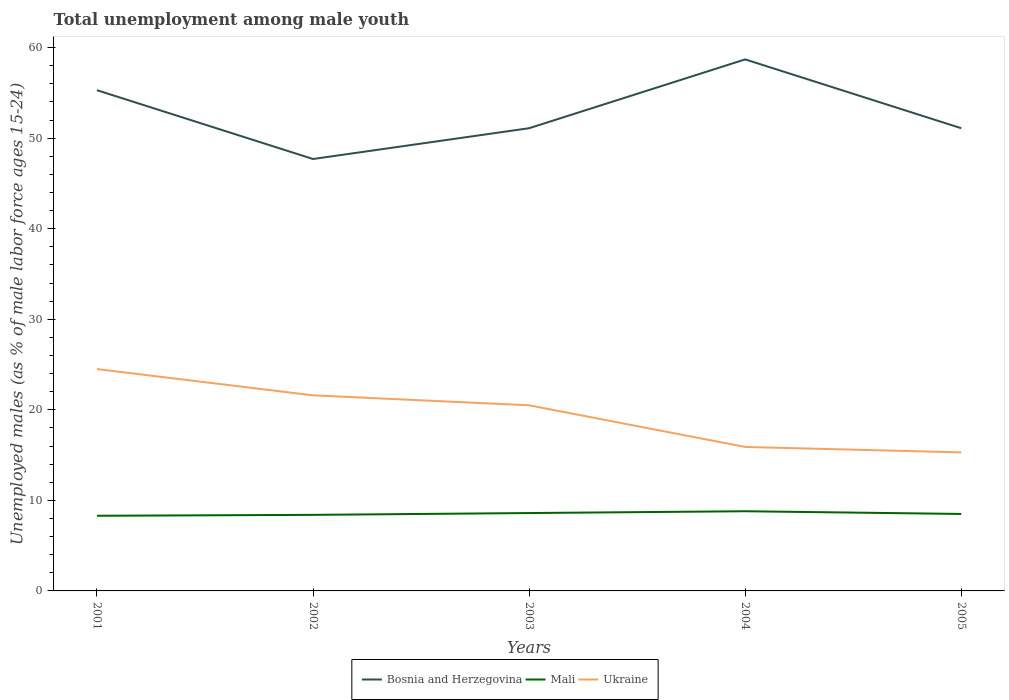Does the line corresponding to Bosnia and Herzegovina intersect with the line corresponding to Mali?
Provide a succinct answer. No. Is the number of lines equal to the number of legend labels?
Ensure brevity in your answer.  Yes. Across all years, what is the maximum percentage of unemployed males in in Bosnia and Herzegovina?
Offer a terse response. 47.7. What is the total percentage of unemployed males in in Bosnia and Herzegovina in the graph?
Provide a short and direct response. -7.6. What is the difference between the highest and the second highest percentage of unemployed males in in Mali?
Make the answer very short. 0.5. What is the difference between the highest and the lowest percentage of unemployed males in in Bosnia and Herzegovina?
Your response must be concise. 2. How many lines are there?
Offer a very short reply. 3. How many years are there in the graph?
Provide a short and direct response. 5. What is the difference between two consecutive major ticks on the Y-axis?
Your answer should be very brief. 10. Where does the legend appear in the graph?
Provide a short and direct response. Bottom center. How many legend labels are there?
Provide a short and direct response. 3. How are the legend labels stacked?
Keep it short and to the point. Horizontal. What is the title of the graph?
Provide a succinct answer. Total unemployment among male youth. What is the label or title of the X-axis?
Your answer should be very brief. Years. What is the label or title of the Y-axis?
Ensure brevity in your answer.  Unemployed males (as % of male labor force ages 15-24). What is the Unemployed males (as % of male labor force ages 15-24) in Bosnia and Herzegovina in 2001?
Your answer should be very brief. 55.3. What is the Unemployed males (as % of male labor force ages 15-24) of Mali in 2001?
Keep it short and to the point. 8.3. What is the Unemployed males (as % of male labor force ages 15-24) in Bosnia and Herzegovina in 2002?
Your response must be concise. 47.7. What is the Unemployed males (as % of male labor force ages 15-24) of Mali in 2002?
Keep it short and to the point. 8.4. What is the Unemployed males (as % of male labor force ages 15-24) of Ukraine in 2002?
Offer a very short reply. 21.6. What is the Unemployed males (as % of male labor force ages 15-24) in Bosnia and Herzegovina in 2003?
Your answer should be very brief. 51.1. What is the Unemployed males (as % of male labor force ages 15-24) of Mali in 2003?
Ensure brevity in your answer.  8.6. What is the Unemployed males (as % of male labor force ages 15-24) of Ukraine in 2003?
Keep it short and to the point. 20.5. What is the Unemployed males (as % of male labor force ages 15-24) in Bosnia and Herzegovina in 2004?
Keep it short and to the point. 58.7. What is the Unemployed males (as % of male labor force ages 15-24) in Mali in 2004?
Make the answer very short. 8.8. What is the Unemployed males (as % of male labor force ages 15-24) of Ukraine in 2004?
Provide a short and direct response. 15.9. What is the Unemployed males (as % of male labor force ages 15-24) of Bosnia and Herzegovina in 2005?
Offer a terse response. 51.1. What is the Unemployed males (as % of male labor force ages 15-24) in Mali in 2005?
Give a very brief answer. 8.5. What is the Unemployed males (as % of male labor force ages 15-24) of Ukraine in 2005?
Make the answer very short. 15.3. Across all years, what is the maximum Unemployed males (as % of male labor force ages 15-24) in Bosnia and Herzegovina?
Ensure brevity in your answer.  58.7. Across all years, what is the maximum Unemployed males (as % of male labor force ages 15-24) of Mali?
Keep it short and to the point. 8.8. Across all years, what is the maximum Unemployed males (as % of male labor force ages 15-24) of Ukraine?
Give a very brief answer. 24.5. Across all years, what is the minimum Unemployed males (as % of male labor force ages 15-24) in Bosnia and Herzegovina?
Offer a very short reply. 47.7. Across all years, what is the minimum Unemployed males (as % of male labor force ages 15-24) of Mali?
Give a very brief answer. 8.3. Across all years, what is the minimum Unemployed males (as % of male labor force ages 15-24) in Ukraine?
Provide a succinct answer. 15.3. What is the total Unemployed males (as % of male labor force ages 15-24) of Bosnia and Herzegovina in the graph?
Provide a succinct answer. 263.9. What is the total Unemployed males (as % of male labor force ages 15-24) in Mali in the graph?
Offer a terse response. 42.6. What is the total Unemployed males (as % of male labor force ages 15-24) of Ukraine in the graph?
Offer a very short reply. 97.8. What is the difference between the Unemployed males (as % of male labor force ages 15-24) of Bosnia and Herzegovina in 2001 and that in 2002?
Provide a short and direct response. 7.6. What is the difference between the Unemployed males (as % of male labor force ages 15-24) of Mali in 2001 and that in 2002?
Your answer should be very brief. -0.1. What is the difference between the Unemployed males (as % of male labor force ages 15-24) in Ukraine in 2001 and that in 2002?
Offer a terse response. 2.9. What is the difference between the Unemployed males (as % of male labor force ages 15-24) in Bosnia and Herzegovina in 2001 and that in 2003?
Provide a succinct answer. 4.2. What is the difference between the Unemployed males (as % of male labor force ages 15-24) of Mali in 2001 and that in 2003?
Your response must be concise. -0.3. What is the difference between the Unemployed males (as % of male labor force ages 15-24) of Mali in 2001 and that in 2004?
Ensure brevity in your answer.  -0.5. What is the difference between the Unemployed males (as % of male labor force ages 15-24) of Mali in 2001 and that in 2005?
Your answer should be very brief. -0.2. What is the difference between the Unemployed males (as % of male labor force ages 15-24) of Ukraine in 2001 and that in 2005?
Provide a succinct answer. 9.2. What is the difference between the Unemployed males (as % of male labor force ages 15-24) of Mali in 2002 and that in 2003?
Offer a very short reply. -0.2. What is the difference between the Unemployed males (as % of male labor force ages 15-24) in Bosnia and Herzegovina in 2002 and that in 2004?
Make the answer very short. -11. What is the difference between the Unemployed males (as % of male labor force ages 15-24) of Mali in 2002 and that in 2004?
Provide a short and direct response. -0.4. What is the difference between the Unemployed males (as % of male labor force ages 15-24) of Bosnia and Herzegovina in 2002 and that in 2005?
Keep it short and to the point. -3.4. What is the difference between the Unemployed males (as % of male labor force ages 15-24) of Bosnia and Herzegovina in 2003 and that in 2004?
Ensure brevity in your answer.  -7.6. What is the difference between the Unemployed males (as % of male labor force ages 15-24) of Mali in 2003 and that in 2004?
Offer a very short reply. -0.2. What is the difference between the Unemployed males (as % of male labor force ages 15-24) of Ukraine in 2003 and that in 2004?
Your answer should be compact. 4.6. What is the difference between the Unemployed males (as % of male labor force ages 15-24) in Mali in 2003 and that in 2005?
Ensure brevity in your answer.  0.1. What is the difference between the Unemployed males (as % of male labor force ages 15-24) in Ukraine in 2003 and that in 2005?
Ensure brevity in your answer.  5.2. What is the difference between the Unemployed males (as % of male labor force ages 15-24) in Bosnia and Herzegovina in 2004 and that in 2005?
Provide a short and direct response. 7.6. What is the difference between the Unemployed males (as % of male labor force ages 15-24) of Mali in 2004 and that in 2005?
Make the answer very short. 0.3. What is the difference between the Unemployed males (as % of male labor force ages 15-24) in Bosnia and Herzegovina in 2001 and the Unemployed males (as % of male labor force ages 15-24) in Mali in 2002?
Provide a succinct answer. 46.9. What is the difference between the Unemployed males (as % of male labor force ages 15-24) of Bosnia and Herzegovina in 2001 and the Unemployed males (as % of male labor force ages 15-24) of Ukraine in 2002?
Make the answer very short. 33.7. What is the difference between the Unemployed males (as % of male labor force ages 15-24) in Bosnia and Herzegovina in 2001 and the Unemployed males (as % of male labor force ages 15-24) in Mali in 2003?
Provide a short and direct response. 46.7. What is the difference between the Unemployed males (as % of male labor force ages 15-24) of Bosnia and Herzegovina in 2001 and the Unemployed males (as % of male labor force ages 15-24) of Ukraine in 2003?
Offer a terse response. 34.8. What is the difference between the Unemployed males (as % of male labor force ages 15-24) of Mali in 2001 and the Unemployed males (as % of male labor force ages 15-24) of Ukraine in 2003?
Make the answer very short. -12.2. What is the difference between the Unemployed males (as % of male labor force ages 15-24) of Bosnia and Herzegovina in 2001 and the Unemployed males (as % of male labor force ages 15-24) of Mali in 2004?
Make the answer very short. 46.5. What is the difference between the Unemployed males (as % of male labor force ages 15-24) in Bosnia and Herzegovina in 2001 and the Unemployed males (as % of male labor force ages 15-24) in Ukraine in 2004?
Ensure brevity in your answer.  39.4. What is the difference between the Unemployed males (as % of male labor force ages 15-24) in Bosnia and Herzegovina in 2001 and the Unemployed males (as % of male labor force ages 15-24) in Mali in 2005?
Your response must be concise. 46.8. What is the difference between the Unemployed males (as % of male labor force ages 15-24) in Bosnia and Herzegovina in 2002 and the Unemployed males (as % of male labor force ages 15-24) in Mali in 2003?
Offer a very short reply. 39.1. What is the difference between the Unemployed males (as % of male labor force ages 15-24) in Bosnia and Herzegovina in 2002 and the Unemployed males (as % of male labor force ages 15-24) in Ukraine in 2003?
Your answer should be compact. 27.2. What is the difference between the Unemployed males (as % of male labor force ages 15-24) in Bosnia and Herzegovina in 2002 and the Unemployed males (as % of male labor force ages 15-24) in Mali in 2004?
Keep it short and to the point. 38.9. What is the difference between the Unemployed males (as % of male labor force ages 15-24) of Bosnia and Herzegovina in 2002 and the Unemployed males (as % of male labor force ages 15-24) of Ukraine in 2004?
Keep it short and to the point. 31.8. What is the difference between the Unemployed males (as % of male labor force ages 15-24) of Bosnia and Herzegovina in 2002 and the Unemployed males (as % of male labor force ages 15-24) of Mali in 2005?
Provide a short and direct response. 39.2. What is the difference between the Unemployed males (as % of male labor force ages 15-24) in Bosnia and Herzegovina in 2002 and the Unemployed males (as % of male labor force ages 15-24) in Ukraine in 2005?
Provide a succinct answer. 32.4. What is the difference between the Unemployed males (as % of male labor force ages 15-24) of Mali in 2002 and the Unemployed males (as % of male labor force ages 15-24) of Ukraine in 2005?
Your answer should be compact. -6.9. What is the difference between the Unemployed males (as % of male labor force ages 15-24) in Bosnia and Herzegovina in 2003 and the Unemployed males (as % of male labor force ages 15-24) in Mali in 2004?
Offer a very short reply. 42.3. What is the difference between the Unemployed males (as % of male labor force ages 15-24) in Bosnia and Herzegovina in 2003 and the Unemployed males (as % of male labor force ages 15-24) in Ukraine in 2004?
Keep it short and to the point. 35.2. What is the difference between the Unemployed males (as % of male labor force ages 15-24) of Mali in 2003 and the Unemployed males (as % of male labor force ages 15-24) of Ukraine in 2004?
Give a very brief answer. -7.3. What is the difference between the Unemployed males (as % of male labor force ages 15-24) in Bosnia and Herzegovina in 2003 and the Unemployed males (as % of male labor force ages 15-24) in Mali in 2005?
Keep it short and to the point. 42.6. What is the difference between the Unemployed males (as % of male labor force ages 15-24) of Bosnia and Herzegovina in 2003 and the Unemployed males (as % of male labor force ages 15-24) of Ukraine in 2005?
Your response must be concise. 35.8. What is the difference between the Unemployed males (as % of male labor force ages 15-24) of Mali in 2003 and the Unemployed males (as % of male labor force ages 15-24) of Ukraine in 2005?
Offer a very short reply. -6.7. What is the difference between the Unemployed males (as % of male labor force ages 15-24) of Bosnia and Herzegovina in 2004 and the Unemployed males (as % of male labor force ages 15-24) of Mali in 2005?
Offer a terse response. 50.2. What is the difference between the Unemployed males (as % of male labor force ages 15-24) in Bosnia and Herzegovina in 2004 and the Unemployed males (as % of male labor force ages 15-24) in Ukraine in 2005?
Offer a very short reply. 43.4. What is the difference between the Unemployed males (as % of male labor force ages 15-24) of Mali in 2004 and the Unemployed males (as % of male labor force ages 15-24) of Ukraine in 2005?
Ensure brevity in your answer.  -6.5. What is the average Unemployed males (as % of male labor force ages 15-24) in Bosnia and Herzegovina per year?
Your answer should be compact. 52.78. What is the average Unemployed males (as % of male labor force ages 15-24) of Mali per year?
Keep it short and to the point. 8.52. What is the average Unemployed males (as % of male labor force ages 15-24) in Ukraine per year?
Provide a short and direct response. 19.56. In the year 2001, what is the difference between the Unemployed males (as % of male labor force ages 15-24) of Bosnia and Herzegovina and Unemployed males (as % of male labor force ages 15-24) of Ukraine?
Your response must be concise. 30.8. In the year 2001, what is the difference between the Unemployed males (as % of male labor force ages 15-24) in Mali and Unemployed males (as % of male labor force ages 15-24) in Ukraine?
Keep it short and to the point. -16.2. In the year 2002, what is the difference between the Unemployed males (as % of male labor force ages 15-24) in Bosnia and Herzegovina and Unemployed males (as % of male labor force ages 15-24) in Mali?
Your answer should be compact. 39.3. In the year 2002, what is the difference between the Unemployed males (as % of male labor force ages 15-24) in Bosnia and Herzegovina and Unemployed males (as % of male labor force ages 15-24) in Ukraine?
Provide a short and direct response. 26.1. In the year 2003, what is the difference between the Unemployed males (as % of male labor force ages 15-24) in Bosnia and Herzegovina and Unemployed males (as % of male labor force ages 15-24) in Mali?
Offer a terse response. 42.5. In the year 2003, what is the difference between the Unemployed males (as % of male labor force ages 15-24) of Bosnia and Herzegovina and Unemployed males (as % of male labor force ages 15-24) of Ukraine?
Provide a short and direct response. 30.6. In the year 2004, what is the difference between the Unemployed males (as % of male labor force ages 15-24) in Bosnia and Herzegovina and Unemployed males (as % of male labor force ages 15-24) in Mali?
Make the answer very short. 49.9. In the year 2004, what is the difference between the Unemployed males (as % of male labor force ages 15-24) of Bosnia and Herzegovina and Unemployed males (as % of male labor force ages 15-24) of Ukraine?
Offer a very short reply. 42.8. In the year 2004, what is the difference between the Unemployed males (as % of male labor force ages 15-24) of Mali and Unemployed males (as % of male labor force ages 15-24) of Ukraine?
Your answer should be compact. -7.1. In the year 2005, what is the difference between the Unemployed males (as % of male labor force ages 15-24) of Bosnia and Herzegovina and Unemployed males (as % of male labor force ages 15-24) of Mali?
Your answer should be very brief. 42.6. In the year 2005, what is the difference between the Unemployed males (as % of male labor force ages 15-24) of Bosnia and Herzegovina and Unemployed males (as % of male labor force ages 15-24) of Ukraine?
Your response must be concise. 35.8. What is the ratio of the Unemployed males (as % of male labor force ages 15-24) in Bosnia and Herzegovina in 2001 to that in 2002?
Your response must be concise. 1.16. What is the ratio of the Unemployed males (as % of male labor force ages 15-24) in Ukraine in 2001 to that in 2002?
Your answer should be compact. 1.13. What is the ratio of the Unemployed males (as % of male labor force ages 15-24) of Bosnia and Herzegovina in 2001 to that in 2003?
Make the answer very short. 1.08. What is the ratio of the Unemployed males (as % of male labor force ages 15-24) of Mali in 2001 to that in 2003?
Keep it short and to the point. 0.97. What is the ratio of the Unemployed males (as % of male labor force ages 15-24) in Ukraine in 2001 to that in 2003?
Make the answer very short. 1.2. What is the ratio of the Unemployed males (as % of male labor force ages 15-24) in Bosnia and Herzegovina in 2001 to that in 2004?
Your response must be concise. 0.94. What is the ratio of the Unemployed males (as % of male labor force ages 15-24) of Mali in 2001 to that in 2004?
Offer a terse response. 0.94. What is the ratio of the Unemployed males (as % of male labor force ages 15-24) of Ukraine in 2001 to that in 2004?
Give a very brief answer. 1.54. What is the ratio of the Unemployed males (as % of male labor force ages 15-24) of Bosnia and Herzegovina in 2001 to that in 2005?
Provide a short and direct response. 1.08. What is the ratio of the Unemployed males (as % of male labor force ages 15-24) in Mali in 2001 to that in 2005?
Make the answer very short. 0.98. What is the ratio of the Unemployed males (as % of male labor force ages 15-24) of Ukraine in 2001 to that in 2005?
Give a very brief answer. 1.6. What is the ratio of the Unemployed males (as % of male labor force ages 15-24) in Bosnia and Herzegovina in 2002 to that in 2003?
Give a very brief answer. 0.93. What is the ratio of the Unemployed males (as % of male labor force ages 15-24) in Mali in 2002 to that in 2003?
Offer a terse response. 0.98. What is the ratio of the Unemployed males (as % of male labor force ages 15-24) in Ukraine in 2002 to that in 2003?
Ensure brevity in your answer.  1.05. What is the ratio of the Unemployed males (as % of male labor force ages 15-24) in Bosnia and Herzegovina in 2002 to that in 2004?
Offer a terse response. 0.81. What is the ratio of the Unemployed males (as % of male labor force ages 15-24) in Mali in 2002 to that in 2004?
Offer a very short reply. 0.95. What is the ratio of the Unemployed males (as % of male labor force ages 15-24) of Ukraine in 2002 to that in 2004?
Your response must be concise. 1.36. What is the ratio of the Unemployed males (as % of male labor force ages 15-24) of Bosnia and Herzegovina in 2002 to that in 2005?
Your response must be concise. 0.93. What is the ratio of the Unemployed males (as % of male labor force ages 15-24) of Ukraine in 2002 to that in 2005?
Your response must be concise. 1.41. What is the ratio of the Unemployed males (as % of male labor force ages 15-24) of Bosnia and Herzegovina in 2003 to that in 2004?
Give a very brief answer. 0.87. What is the ratio of the Unemployed males (as % of male labor force ages 15-24) in Mali in 2003 to that in 2004?
Provide a succinct answer. 0.98. What is the ratio of the Unemployed males (as % of male labor force ages 15-24) of Ukraine in 2003 to that in 2004?
Give a very brief answer. 1.29. What is the ratio of the Unemployed males (as % of male labor force ages 15-24) in Mali in 2003 to that in 2005?
Your response must be concise. 1.01. What is the ratio of the Unemployed males (as % of male labor force ages 15-24) of Ukraine in 2003 to that in 2005?
Give a very brief answer. 1.34. What is the ratio of the Unemployed males (as % of male labor force ages 15-24) of Bosnia and Herzegovina in 2004 to that in 2005?
Your answer should be very brief. 1.15. What is the ratio of the Unemployed males (as % of male labor force ages 15-24) of Mali in 2004 to that in 2005?
Offer a terse response. 1.04. What is the ratio of the Unemployed males (as % of male labor force ages 15-24) in Ukraine in 2004 to that in 2005?
Provide a succinct answer. 1.04. What is the difference between the highest and the second highest Unemployed males (as % of male labor force ages 15-24) in Bosnia and Herzegovina?
Provide a short and direct response. 3.4. What is the difference between the highest and the lowest Unemployed males (as % of male labor force ages 15-24) in Bosnia and Herzegovina?
Your answer should be very brief. 11. What is the difference between the highest and the lowest Unemployed males (as % of male labor force ages 15-24) in Mali?
Your answer should be compact. 0.5. 